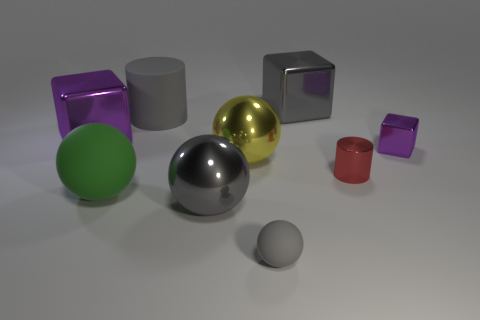Which objects in the picture could feasibly float on water? Assuming they are hollow or have a density less than water, the smaller objects such as the little pink cube and the small red cylinder could feasibly float due to their size and shape potentially displacing enough water to support their weight. 